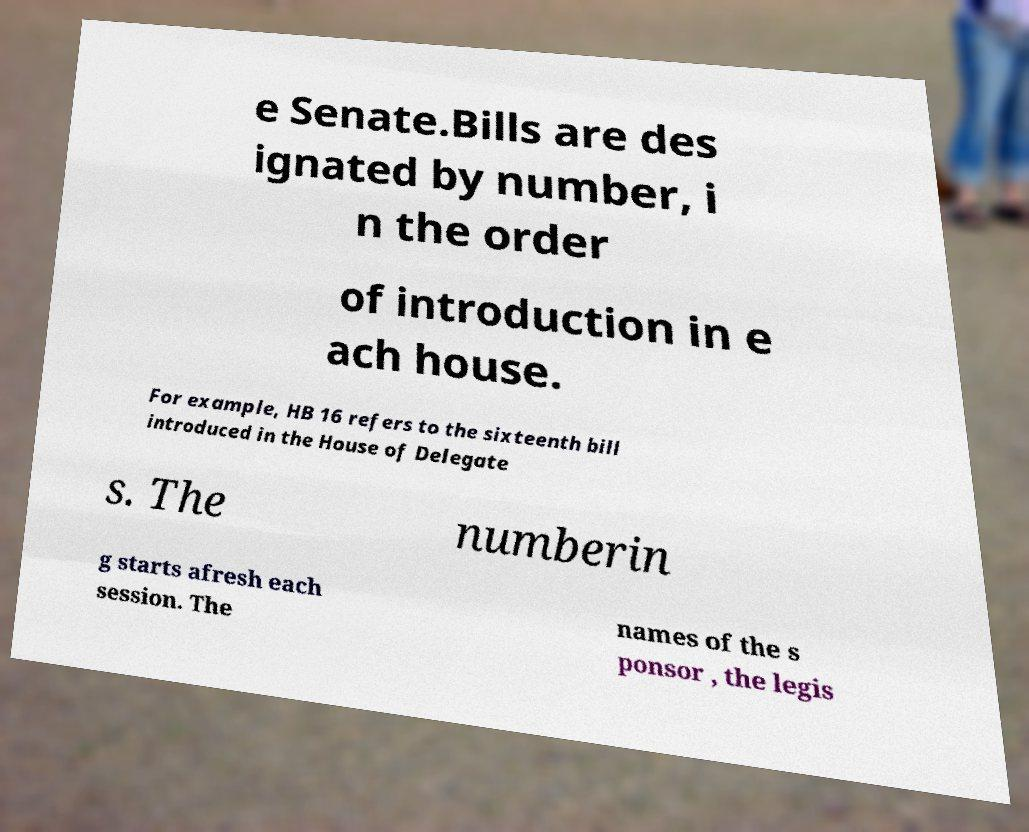Can you read and provide the text displayed in the image?This photo seems to have some interesting text. Can you extract and type it out for me? e Senate.Bills are des ignated by number, i n the order of introduction in e ach house. For example, HB 16 refers to the sixteenth bill introduced in the House of Delegate s. The numberin g starts afresh each session. The names of the s ponsor , the legis 